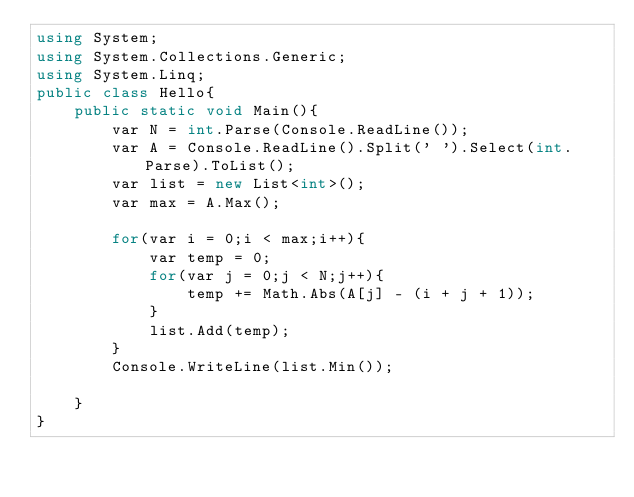<code> <loc_0><loc_0><loc_500><loc_500><_C#_>using System;
using System.Collections.Generic;
using System.Linq;
public class Hello{
    public static void Main(){
        var N = int.Parse(Console.ReadLine());
        var A = Console.ReadLine().Split(' ').Select(int.Parse).ToList();
        var list = new List<int>();
        var max = A.Max();
        
        for(var i = 0;i < max;i++){
            var temp = 0;
            for(var j = 0;j < N;j++){
                temp += Math.Abs(A[j] - (i + j + 1));
            }
            list.Add(temp);
        }
        Console.WriteLine(list.Min());
        
    }
}
</code> 